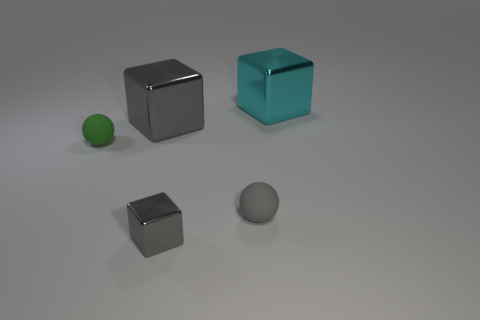Add 5 small gray matte things. How many objects exist? 10 Subtract all cyan metal blocks. How many blocks are left? 2 Subtract 1 spheres. How many spheres are left? 1 Subtract all balls. How many objects are left? 3 Subtract all yellow balls. Subtract all cyan cylinders. How many balls are left? 2 Subtract all cyan blocks. How many purple spheres are left? 0 Subtract all tiny blocks. Subtract all cyan objects. How many objects are left? 3 Add 1 small green things. How many small green things are left? 2 Add 4 tiny things. How many tiny things exist? 7 Subtract all green balls. How many balls are left? 1 